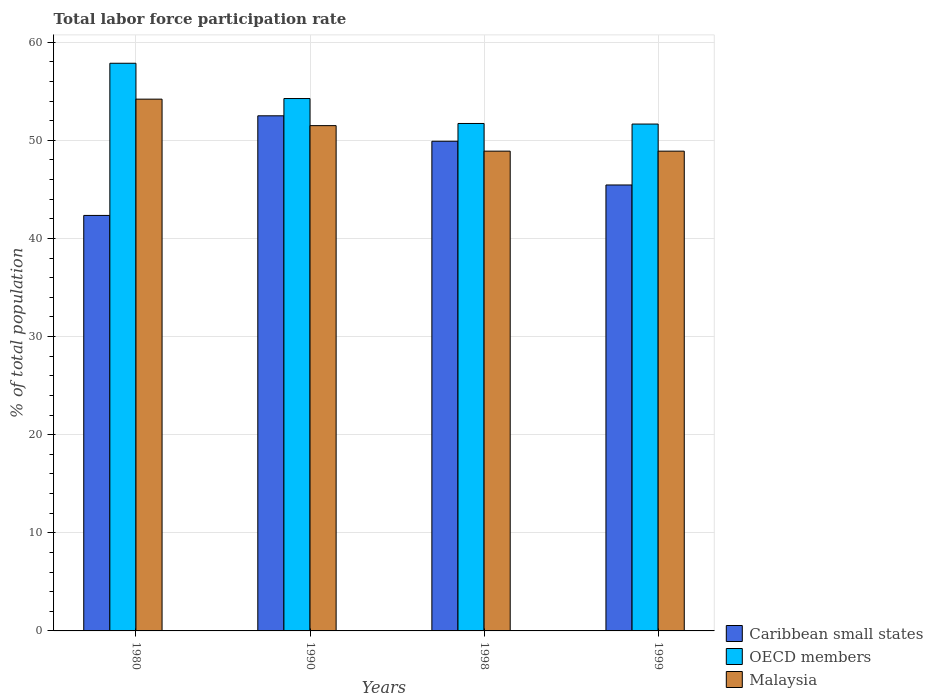Are the number of bars per tick equal to the number of legend labels?
Your answer should be compact. Yes. Are the number of bars on each tick of the X-axis equal?
Make the answer very short. Yes. How many bars are there on the 3rd tick from the left?
Keep it short and to the point. 3. What is the total labor force participation rate in OECD members in 1990?
Offer a terse response. 54.26. Across all years, what is the maximum total labor force participation rate in OECD members?
Make the answer very short. 57.86. Across all years, what is the minimum total labor force participation rate in Malaysia?
Ensure brevity in your answer.  48.9. In which year was the total labor force participation rate in Caribbean small states minimum?
Give a very brief answer. 1980. What is the total total labor force participation rate in OECD members in the graph?
Ensure brevity in your answer.  215.5. What is the difference between the total labor force participation rate in Caribbean small states in 1980 and that in 1998?
Your answer should be compact. -7.56. What is the difference between the total labor force participation rate in Caribbean small states in 1999 and the total labor force participation rate in OECD members in 1980?
Provide a succinct answer. -12.41. What is the average total labor force participation rate in Caribbean small states per year?
Make the answer very short. 47.55. In the year 1990, what is the difference between the total labor force participation rate in Malaysia and total labor force participation rate in OECD members?
Provide a succinct answer. -2.76. In how many years, is the total labor force participation rate in Caribbean small states greater than 26 %?
Provide a short and direct response. 4. What is the ratio of the total labor force participation rate in Caribbean small states in 1990 to that in 1998?
Your response must be concise. 1.05. Is the total labor force participation rate in OECD members in 1980 less than that in 1998?
Provide a succinct answer. No. What is the difference between the highest and the second highest total labor force participation rate in OECD members?
Offer a very short reply. 3.6. What is the difference between the highest and the lowest total labor force participation rate in Caribbean small states?
Keep it short and to the point. 10.15. What does the 2nd bar from the left in 1990 represents?
Offer a terse response. OECD members. What does the 2nd bar from the right in 1980 represents?
Make the answer very short. OECD members. How many bars are there?
Provide a short and direct response. 12. Are all the bars in the graph horizontal?
Your answer should be very brief. No. How many years are there in the graph?
Offer a terse response. 4. Are the values on the major ticks of Y-axis written in scientific E-notation?
Provide a short and direct response. No. Does the graph contain any zero values?
Ensure brevity in your answer.  No. How many legend labels are there?
Provide a succinct answer. 3. What is the title of the graph?
Your answer should be compact. Total labor force participation rate. Does "Costa Rica" appear as one of the legend labels in the graph?
Provide a short and direct response. No. What is the label or title of the X-axis?
Provide a succinct answer. Years. What is the label or title of the Y-axis?
Ensure brevity in your answer.  % of total population. What is the % of total population of Caribbean small states in 1980?
Provide a short and direct response. 42.35. What is the % of total population of OECD members in 1980?
Your answer should be compact. 57.86. What is the % of total population in Malaysia in 1980?
Your answer should be very brief. 54.2. What is the % of total population in Caribbean small states in 1990?
Make the answer very short. 52.5. What is the % of total population in OECD members in 1990?
Your answer should be very brief. 54.26. What is the % of total population of Malaysia in 1990?
Provide a short and direct response. 51.5. What is the % of total population in Caribbean small states in 1998?
Give a very brief answer. 49.91. What is the % of total population of OECD members in 1998?
Make the answer very short. 51.72. What is the % of total population in Malaysia in 1998?
Offer a very short reply. 48.9. What is the % of total population in Caribbean small states in 1999?
Provide a succinct answer. 45.45. What is the % of total population of OECD members in 1999?
Your answer should be compact. 51.66. What is the % of total population of Malaysia in 1999?
Your answer should be very brief. 48.9. Across all years, what is the maximum % of total population in Caribbean small states?
Your answer should be compact. 52.5. Across all years, what is the maximum % of total population in OECD members?
Keep it short and to the point. 57.86. Across all years, what is the maximum % of total population of Malaysia?
Keep it short and to the point. 54.2. Across all years, what is the minimum % of total population of Caribbean small states?
Make the answer very short. 42.35. Across all years, what is the minimum % of total population in OECD members?
Offer a very short reply. 51.66. Across all years, what is the minimum % of total population in Malaysia?
Offer a very short reply. 48.9. What is the total % of total population of Caribbean small states in the graph?
Make the answer very short. 190.21. What is the total % of total population in OECD members in the graph?
Offer a terse response. 215.5. What is the total % of total population in Malaysia in the graph?
Your response must be concise. 203.5. What is the difference between the % of total population in Caribbean small states in 1980 and that in 1990?
Provide a succinct answer. -10.15. What is the difference between the % of total population of OECD members in 1980 and that in 1990?
Keep it short and to the point. 3.6. What is the difference between the % of total population of Caribbean small states in 1980 and that in 1998?
Your answer should be compact. -7.56. What is the difference between the % of total population in OECD members in 1980 and that in 1998?
Provide a succinct answer. 6.14. What is the difference between the % of total population in Caribbean small states in 1980 and that in 1999?
Offer a very short reply. -3.1. What is the difference between the % of total population in OECD members in 1980 and that in 1999?
Your answer should be compact. 6.2. What is the difference between the % of total population in Caribbean small states in 1990 and that in 1998?
Make the answer very short. 2.59. What is the difference between the % of total population of OECD members in 1990 and that in 1998?
Provide a short and direct response. 2.54. What is the difference between the % of total population of Caribbean small states in 1990 and that in 1999?
Offer a terse response. 7.05. What is the difference between the % of total population in OECD members in 1990 and that in 1999?
Ensure brevity in your answer.  2.6. What is the difference between the % of total population in Malaysia in 1990 and that in 1999?
Keep it short and to the point. 2.6. What is the difference between the % of total population in Caribbean small states in 1998 and that in 1999?
Keep it short and to the point. 4.46. What is the difference between the % of total population in OECD members in 1998 and that in 1999?
Offer a very short reply. 0.06. What is the difference between the % of total population in Malaysia in 1998 and that in 1999?
Keep it short and to the point. 0. What is the difference between the % of total population of Caribbean small states in 1980 and the % of total population of OECD members in 1990?
Make the answer very short. -11.91. What is the difference between the % of total population of Caribbean small states in 1980 and the % of total population of Malaysia in 1990?
Provide a succinct answer. -9.15. What is the difference between the % of total population in OECD members in 1980 and the % of total population in Malaysia in 1990?
Make the answer very short. 6.36. What is the difference between the % of total population of Caribbean small states in 1980 and the % of total population of OECD members in 1998?
Give a very brief answer. -9.37. What is the difference between the % of total population of Caribbean small states in 1980 and the % of total population of Malaysia in 1998?
Offer a very short reply. -6.55. What is the difference between the % of total population in OECD members in 1980 and the % of total population in Malaysia in 1998?
Provide a short and direct response. 8.96. What is the difference between the % of total population of Caribbean small states in 1980 and the % of total population of OECD members in 1999?
Offer a terse response. -9.31. What is the difference between the % of total population of Caribbean small states in 1980 and the % of total population of Malaysia in 1999?
Your answer should be compact. -6.55. What is the difference between the % of total population in OECD members in 1980 and the % of total population in Malaysia in 1999?
Provide a short and direct response. 8.96. What is the difference between the % of total population in Caribbean small states in 1990 and the % of total population in OECD members in 1998?
Provide a succinct answer. 0.78. What is the difference between the % of total population in Caribbean small states in 1990 and the % of total population in Malaysia in 1998?
Ensure brevity in your answer.  3.6. What is the difference between the % of total population in OECD members in 1990 and the % of total population in Malaysia in 1998?
Offer a terse response. 5.36. What is the difference between the % of total population in Caribbean small states in 1990 and the % of total population in OECD members in 1999?
Provide a succinct answer. 0.84. What is the difference between the % of total population in Caribbean small states in 1990 and the % of total population in Malaysia in 1999?
Your answer should be compact. 3.6. What is the difference between the % of total population in OECD members in 1990 and the % of total population in Malaysia in 1999?
Ensure brevity in your answer.  5.36. What is the difference between the % of total population of Caribbean small states in 1998 and the % of total population of OECD members in 1999?
Offer a very short reply. -1.75. What is the difference between the % of total population of Caribbean small states in 1998 and the % of total population of Malaysia in 1999?
Offer a very short reply. 1.01. What is the difference between the % of total population of OECD members in 1998 and the % of total population of Malaysia in 1999?
Keep it short and to the point. 2.82. What is the average % of total population in Caribbean small states per year?
Provide a short and direct response. 47.55. What is the average % of total population of OECD members per year?
Provide a succinct answer. 53.88. What is the average % of total population in Malaysia per year?
Ensure brevity in your answer.  50.88. In the year 1980, what is the difference between the % of total population of Caribbean small states and % of total population of OECD members?
Ensure brevity in your answer.  -15.51. In the year 1980, what is the difference between the % of total population of Caribbean small states and % of total population of Malaysia?
Your response must be concise. -11.85. In the year 1980, what is the difference between the % of total population in OECD members and % of total population in Malaysia?
Make the answer very short. 3.66. In the year 1990, what is the difference between the % of total population of Caribbean small states and % of total population of OECD members?
Ensure brevity in your answer.  -1.76. In the year 1990, what is the difference between the % of total population in Caribbean small states and % of total population in Malaysia?
Your answer should be compact. 1. In the year 1990, what is the difference between the % of total population of OECD members and % of total population of Malaysia?
Provide a short and direct response. 2.76. In the year 1998, what is the difference between the % of total population of Caribbean small states and % of total population of OECD members?
Offer a very short reply. -1.81. In the year 1998, what is the difference between the % of total population in Caribbean small states and % of total population in Malaysia?
Ensure brevity in your answer.  1.01. In the year 1998, what is the difference between the % of total population in OECD members and % of total population in Malaysia?
Provide a succinct answer. 2.82. In the year 1999, what is the difference between the % of total population of Caribbean small states and % of total population of OECD members?
Make the answer very short. -6.21. In the year 1999, what is the difference between the % of total population of Caribbean small states and % of total population of Malaysia?
Provide a succinct answer. -3.45. In the year 1999, what is the difference between the % of total population in OECD members and % of total population in Malaysia?
Offer a terse response. 2.76. What is the ratio of the % of total population of Caribbean small states in 1980 to that in 1990?
Your answer should be compact. 0.81. What is the ratio of the % of total population of OECD members in 1980 to that in 1990?
Provide a short and direct response. 1.07. What is the ratio of the % of total population in Malaysia in 1980 to that in 1990?
Ensure brevity in your answer.  1.05. What is the ratio of the % of total population of Caribbean small states in 1980 to that in 1998?
Offer a terse response. 0.85. What is the ratio of the % of total population in OECD members in 1980 to that in 1998?
Your answer should be very brief. 1.12. What is the ratio of the % of total population of Malaysia in 1980 to that in 1998?
Provide a short and direct response. 1.11. What is the ratio of the % of total population in Caribbean small states in 1980 to that in 1999?
Ensure brevity in your answer.  0.93. What is the ratio of the % of total population in OECD members in 1980 to that in 1999?
Make the answer very short. 1.12. What is the ratio of the % of total population in Malaysia in 1980 to that in 1999?
Keep it short and to the point. 1.11. What is the ratio of the % of total population of Caribbean small states in 1990 to that in 1998?
Keep it short and to the point. 1.05. What is the ratio of the % of total population in OECD members in 1990 to that in 1998?
Keep it short and to the point. 1.05. What is the ratio of the % of total population in Malaysia in 1990 to that in 1998?
Your response must be concise. 1.05. What is the ratio of the % of total population of Caribbean small states in 1990 to that in 1999?
Provide a succinct answer. 1.16. What is the ratio of the % of total population of OECD members in 1990 to that in 1999?
Offer a very short reply. 1.05. What is the ratio of the % of total population of Malaysia in 1990 to that in 1999?
Make the answer very short. 1.05. What is the ratio of the % of total population of Caribbean small states in 1998 to that in 1999?
Keep it short and to the point. 1.1. What is the ratio of the % of total population of Malaysia in 1998 to that in 1999?
Make the answer very short. 1. What is the difference between the highest and the second highest % of total population in Caribbean small states?
Provide a succinct answer. 2.59. What is the difference between the highest and the second highest % of total population in OECD members?
Give a very brief answer. 3.6. What is the difference between the highest and the lowest % of total population of Caribbean small states?
Make the answer very short. 10.15. What is the difference between the highest and the lowest % of total population in OECD members?
Provide a short and direct response. 6.2. 